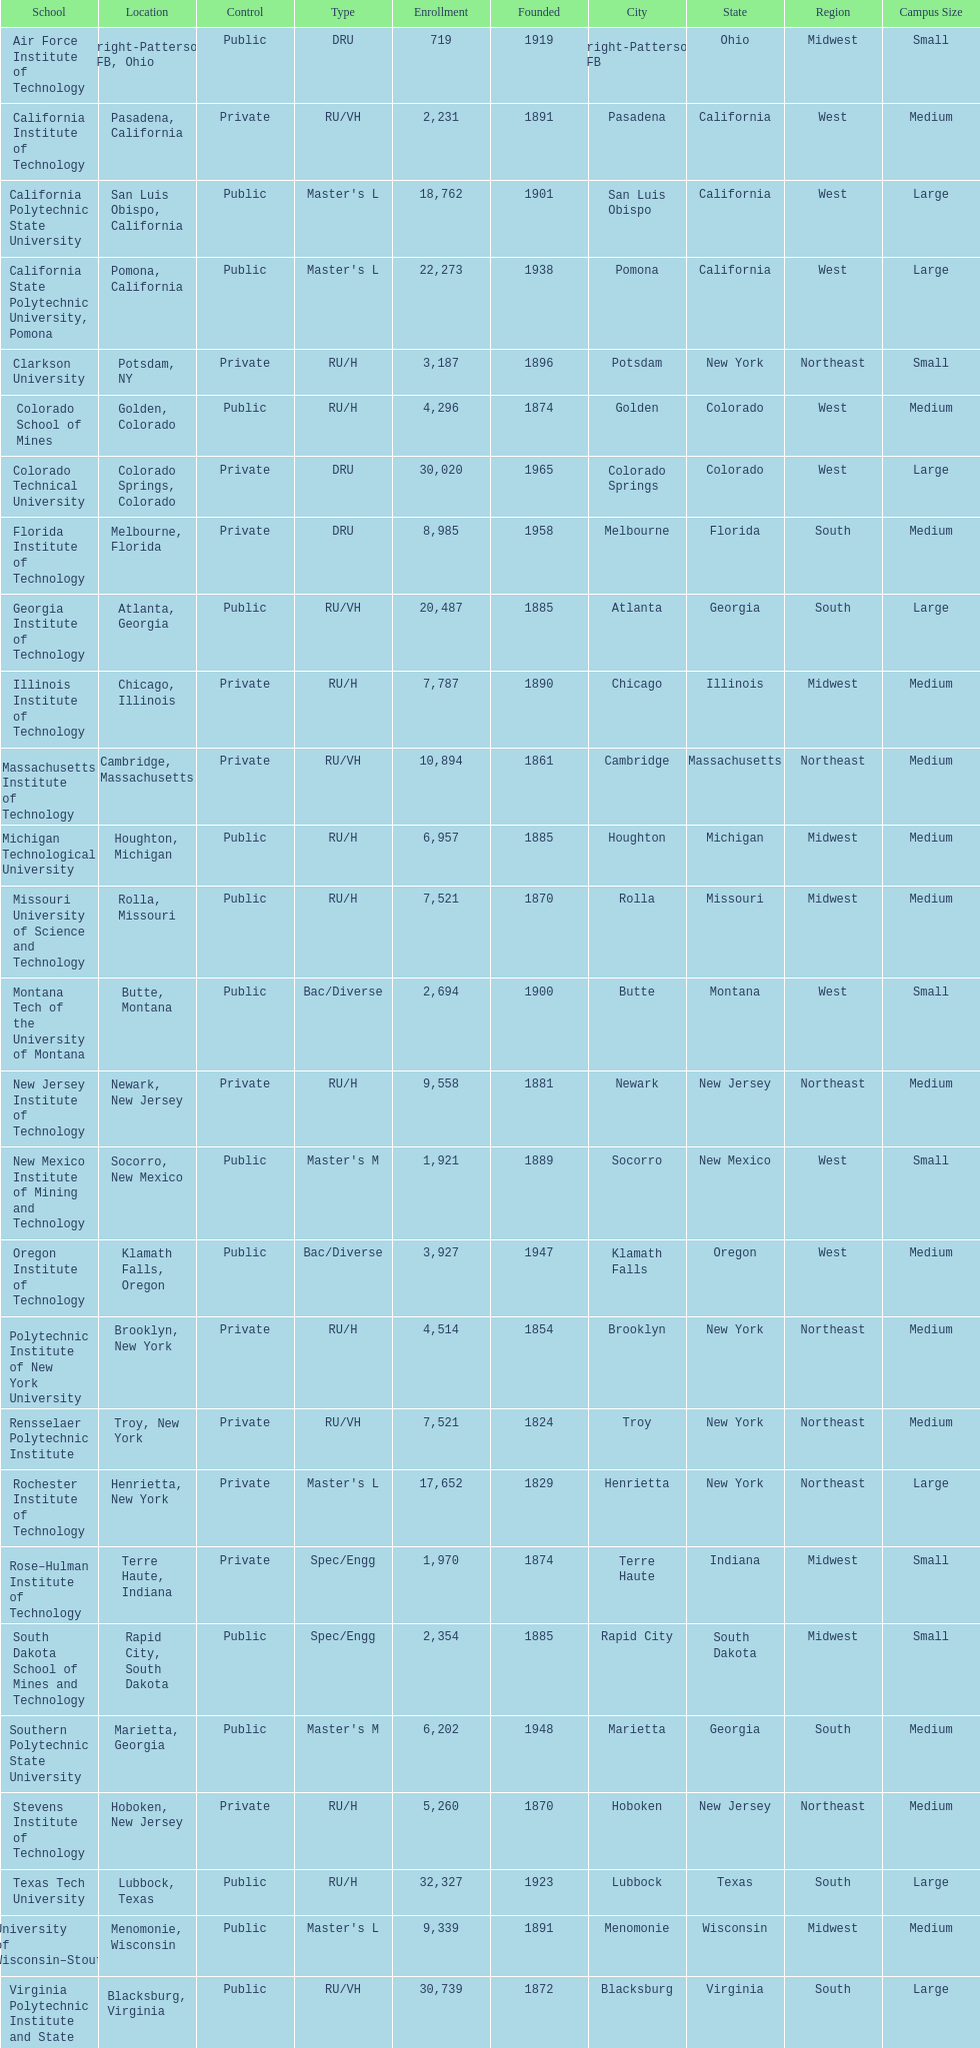How many of the universities were located in california? 3. 